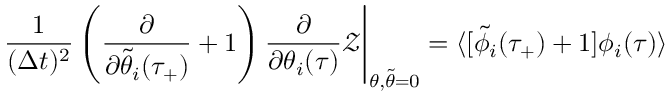<formula> <loc_0><loc_0><loc_500><loc_500>\frac { 1 } { ( \Delta t ) ^ { 2 } } \left ( \frac { \partial } { \partial \tilde { \theta } _ { i } ( \tau _ { + } ) } + 1 \right ) \frac { \partial } { \partial \theta _ { i } ( \tau ) } \mathcal { Z } \Big | _ { \theta , \tilde { \theta } = 0 } = \langle [ \tilde { \phi } _ { i } ( \tau _ { + } ) + 1 ] \phi _ { i } ( \tau ) \rangle</formula> 